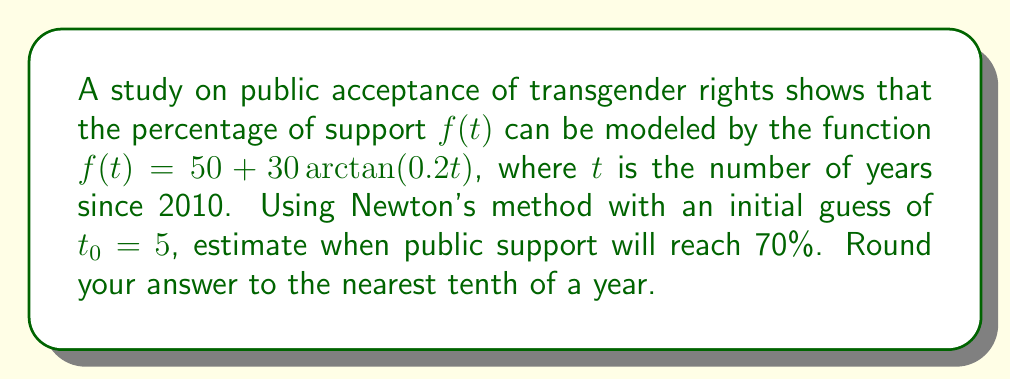What is the answer to this math problem? To solve this problem using Newton's method, we need to follow these steps:

1) First, we set up the equation:
   $f(t) = 70$
   $50 + 30\arctan(0.2t) = 70$
   $30\arctan(0.2t) = 20$
   $\arctan(0.2t) = \frac{2}{3}$

2) Let $g(t) = \arctan(0.2t) - \frac{2}{3}$. We need to find the root of $g(t)$.

3) Newton's method formula:
   $t_{n+1} = t_n - \frac{g(t_n)}{g'(t_n)}$

4) Calculate $g'(t)$:
   $g'(t) = \frac{0.2}{1+(0.2t)^2}$

5) Starting with $t_0 = 5$, let's iterate:

   $t_1 = 5 - \frac{\arctan(0.2 \cdot 5) - \frac{2}{3}}{\frac{0.2}{1+(0.2 \cdot 5)^2}}$
        $\approx 7.0834$

   $t_2 = 7.0834 - \frac{\arctan(0.2 \cdot 7.0834) - \frac{2}{3}}{\frac{0.2}{1+(0.2 \cdot 7.0834)^2}}$
        $\approx 7.1853$

   $t_3 = 7.1853 - \frac{\arctan(0.2 \cdot 7.1853) - \frac{2}{3}}{\frac{0.2}{1+(0.2 \cdot 7.1853)^2}}$
        $\approx 7.1854$

6) The process converges at $t_3$, so we round to the nearest tenth.
Answer: $7.2$ years after 2010 